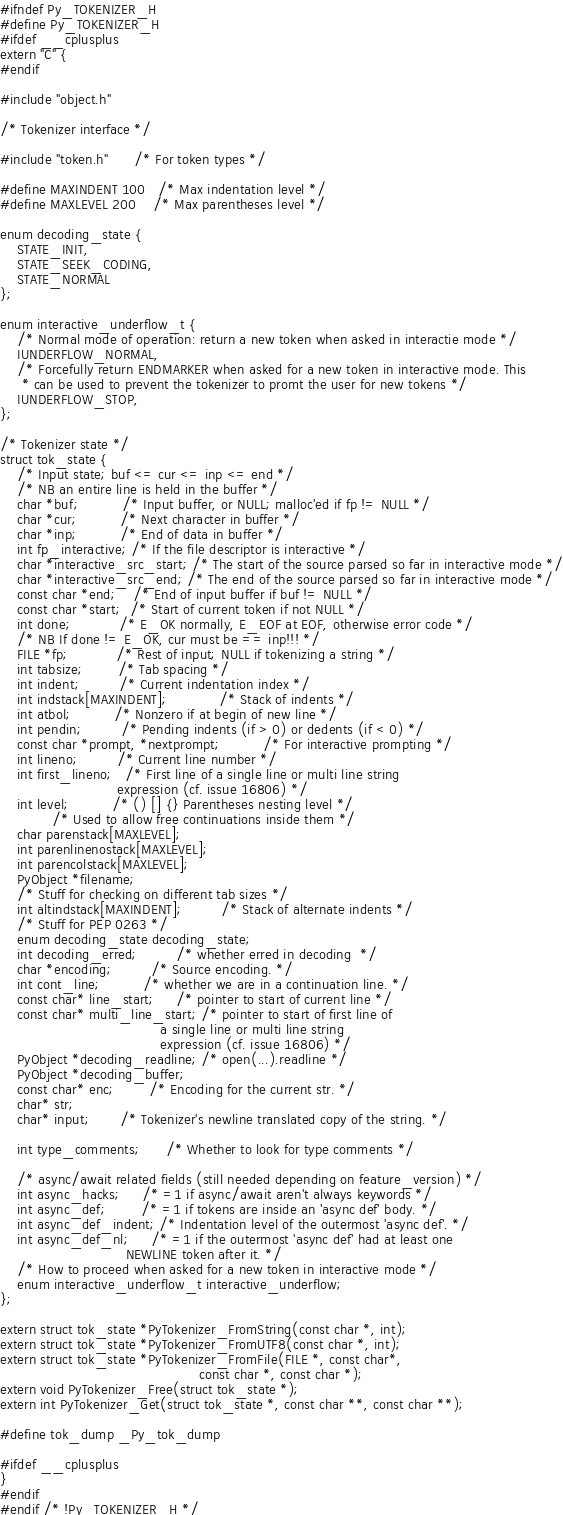Convert code to text. <code><loc_0><loc_0><loc_500><loc_500><_C_>#ifndef Py_TOKENIZER_H
#define Py_TOKENIZER_H
#ifdef __cplusplus
extern "C" {
#endif

#include "object.h"

/* Tokenizer interface */

#include "token.h"      /* For token types */

#define MAXINDENT 100   /* Max indentation level */
#define MAXLEVEL 200    /* Max parentheses level */

enum decoding_state {
    STATE_INIT,
    STATE_SEEK_CODING,
    STATE_NORMAL
};

enum interactive_underflow_t {
    /* Normal mode of operation: return a new token when asked in interactie mode */
    IUNDERFLOW_NORMAL,
    /* Forcefully return ENDMARKER when asked for a new token in interactive mode. This
     * can be used to prevent the tokenizer to promt the user for new tokens */
    IUNDERFLOW_STOP,
};

/* Tokenizer state */
struct tok_state {
    /* Input state; buf <= cur <= inp <= end */
    /* NB an entire line is held in the buffer */
    char *buf;          /* Input buffer, or NULL; malloc'ed if fp != NULL */
    char *cur;          /* Next character in buffer */
    char *inp;          /* End of data in buffer */
    int fp_interactive; /* If the file descriptor is interactive */
    char *interactive_src_start; /* The start of the source parsed so far in interactive mode */
    char *interactive_src_end; /* The end of the source parsed so far in interactive mode */
    const char *end;    /* End of input buffer if buf != NULL */
    const char *start;  /* Start of current token if not NULL */
    int done;           /* E_OK normally, E_EOF at EOF, otherwise error code */
    /* NB If done != E_OK, cur must be == inp!!! */
    FILE *fp;           /* Rest of input; NULL if tokenizing a string */
    int tabsize;        /* Tab spacing */
    int indent;         /* Current indentation index */
    int indstack[MAXINDENT];            /* Stack of indents */
    int atbol;          /* Nonzero if at begin of new line */
    int pendin;         /* Pending indents (if > 0) or dedents (if < 0) */
    const char *prompt, *nextprompt;          /* For interactive prompting */
    int lineno;         /* Current line number */
    int first_lineno;   /* First line of a single line or multi line string
                           expression (cf. issue 16806) */
    int level;          /* () [] {} Parentheses nesting level */
            /* Used to allow free continuations inside them */
    char parenstack[MAXLEVEL];
    int parenlinenostack[MAXLEVEL];
    int parencolstack[MAXLEVEL];
    PyObject *filename;
    /* Stuff for checking on different tab sizes */
    int altindstack[MAXINDENT];         /* Stack of alternate indents */
    /* Stuff for PEP 0263 */
    enum decoding_state decoding_state;
    int decoding_erred;         /* whether erred in decoding  */
    char *encoding;         /* Source encoding. */
    int cont_line;          /* whether we are in a continuation line. */
    const char* line_start;     /* pointer to start of current line */
    const char* multi_line_start; /* pointer to start of first line of
                                     a single line or multi line string
                                     expression (cf. issue 16806) */
    PyObject *decoding_readline; /* open(...).readline */
    PyObject *decoding_buffer;
    const char* enc;        /* Encoding for the current str. */
    char* str;
    char* input;       /* Tokenizer's newline translated copy of the string. */

    int type_comments;      /* Whether to look for type comments */

    /* async/await related fields (still needed depending on feature_version) */
    int async_hacks;     /* =1 if async/await aren't always keywords */
    int async_def;        /* =1 if tokens are inside an 'async def' body. */
    int async_def_indent; /* Indentation level of the outermost 'async def'. */
    int async_def_nl;     /* =1 if the outermost 'async def' had at least one
                             NEWLINE token after it. */
    /* How to proceed when asked for a new token in interactive mode */
    enum interactive_underflow_t interactive_underflow; 
};

extern struct tok_state *PyTokenizer_FromString(const char *, int);
extern struct tok_state *PyTokenizer_FromUTF8(const char *, int);
extern struct tok_state *PyTokenizer_FromFile(FILE *, const char*,
                                              const char *, const char *);
extern void PyTokenizer_Free(struct tok_state *);
extern int PyTokenizer_Get(struct tok_state *, const char **, const char **);

#define tok_dump _Py_tok_dump

#ifdef __cplusplus
}
#endif
#endif /* !Py_TOKENIZER_H */
</code> 